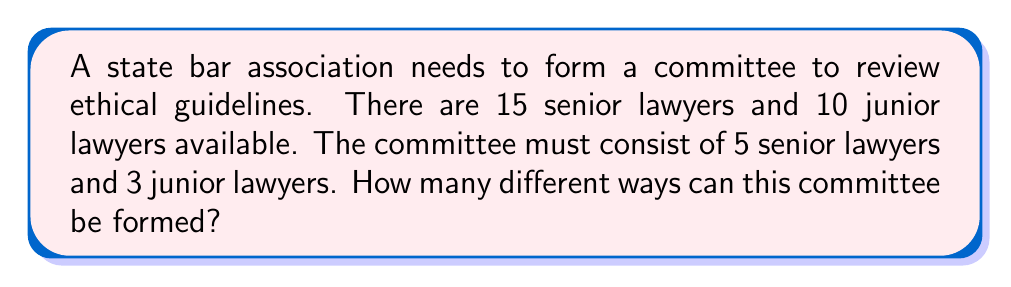Provide a solution to this math problem. Let's approach this step-by-step using the combination formula:

1) For the senior lawyers:
   We need to choose 5 out of 15 senior lawyers. This can be done in $\binom{15}{5}$ ways.
   
   $$\binom{15}{5} = \frac{15!}{5!(15-5)!} = \frac{15!}{5!10!}$$

2) For the junior lawyers:
   We need to choose 3 out of 10 junior lawyers. This can be done in $\binom{10}{3}$ ways.
   
   $$\binom{10}{3} = \frac{10!}{3!(10-3)!} = \frac{10!}{3!7!}$$

3) By the Multiplication Principle, the total number of ways to form the committee is:

   $$\binom{15}{5} \times \binom{10}{3}$$

4) Let's calculate each part:
   
   $$\binom{15}{5} = 3003$$
   $$\binom{10}{3} = 120$$

5) Therefore, the total number of ways is:

   $$3003 \times 120 = 360,360$$
Answer: 360,360 